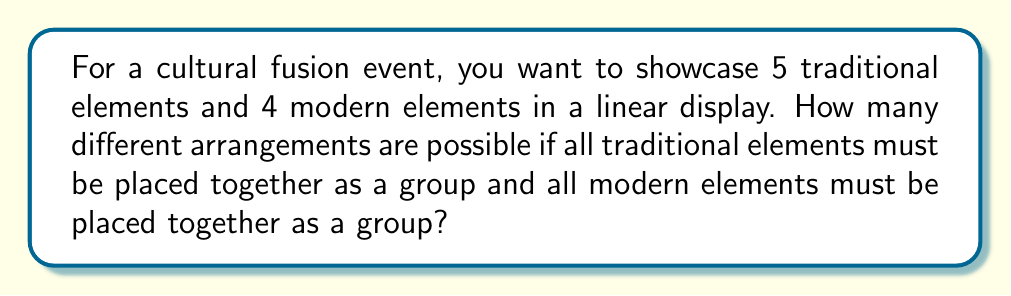Could you help me with this problem? Let's approach this step-by-step:

1) First, we need to consider the traditional and modern element groups as two distinct units. So, we essentially have 2 items to arrange.

2) The number of ways to arrange 2 items is simply 2! = 2 × 1 = 2.

3) Now, within the traditional group, we have 5 elements that can be arranged in different ways. The number of arrangements for 5 items is 5! = 5 × 4 × 3 × 2 × 1 = 120.

4) Similarly, within the modern group, we have 4 elements. The number of arrangements for 4 items is 4! = 4 × 3 × 2 × 1 = 24.

5) According to the Multiplication Principle, if we have m ways of doing something and n ways of doing another thing, then there are m × n ways of doing both things.

6) Therefore, the total number of possible arrangements is:

   $$ 2! \times 5! \times 4! = 2 \times 120 \times 24 = 5,760 $$

This calculation considers all possible arrangements of the two groups, as well as all possible arrangements within each group.
Answer: 5,760 